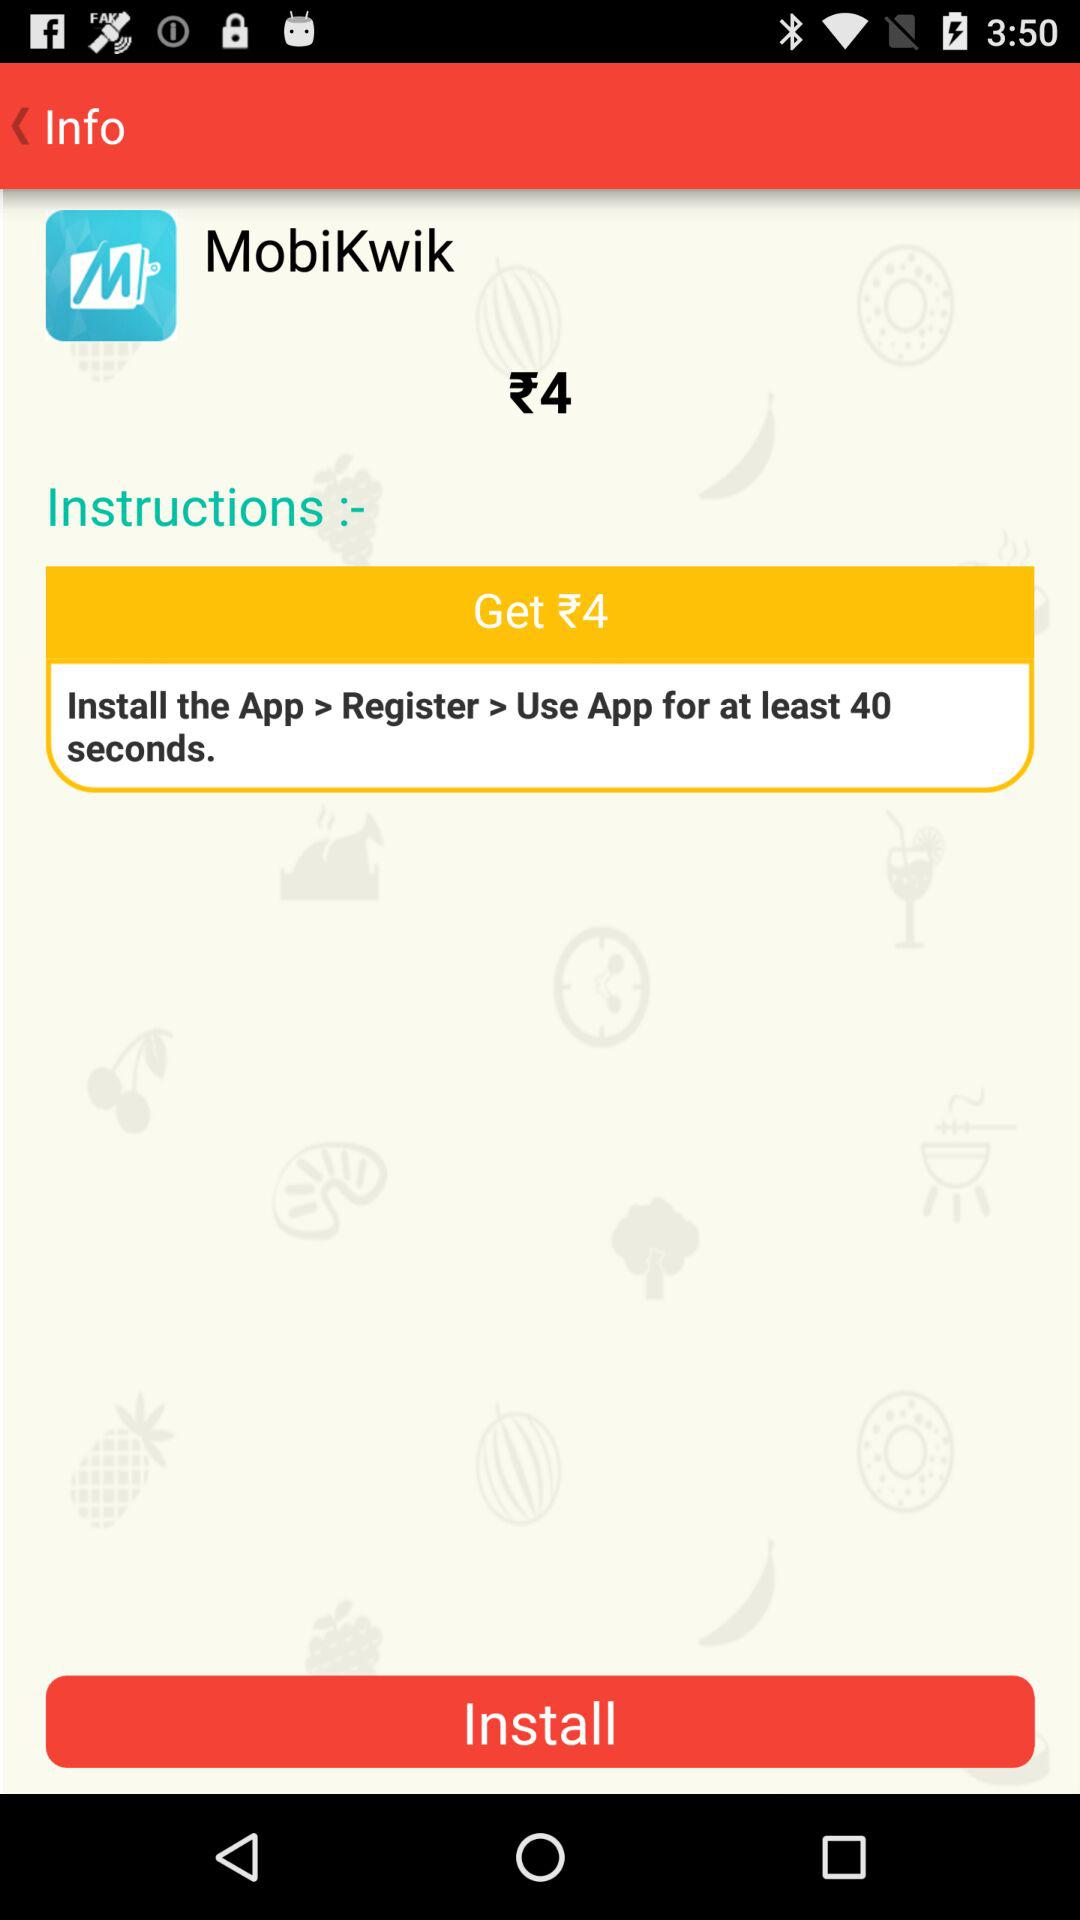What is the application name? The application name is "MobiKwik". 